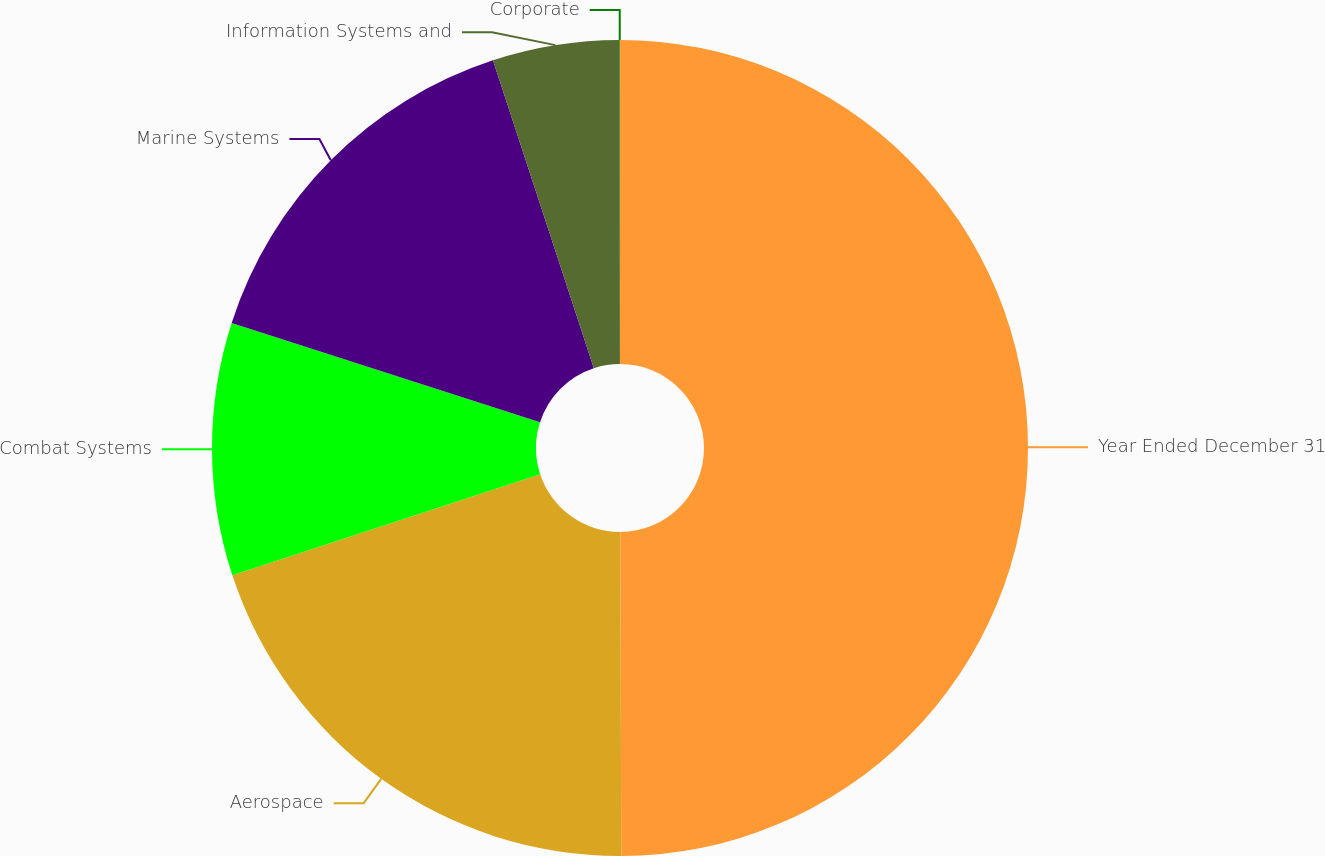Convert chart to OTSL. <chart><loc_0><loc_0><loc_500><loc_500><pie_chart><fcel>Year Ended December 31<fcel>Aerospace<fcel>Combat Systems<fcel>Marine Systems<fcel>Information Systems and<fcel>Corporate<nl><fcel>49.95%<fcel>20.0%<fcel>10.01%<fcel>15.0%<fcel>5.02%<fcel>0.02%<nl></chart> 